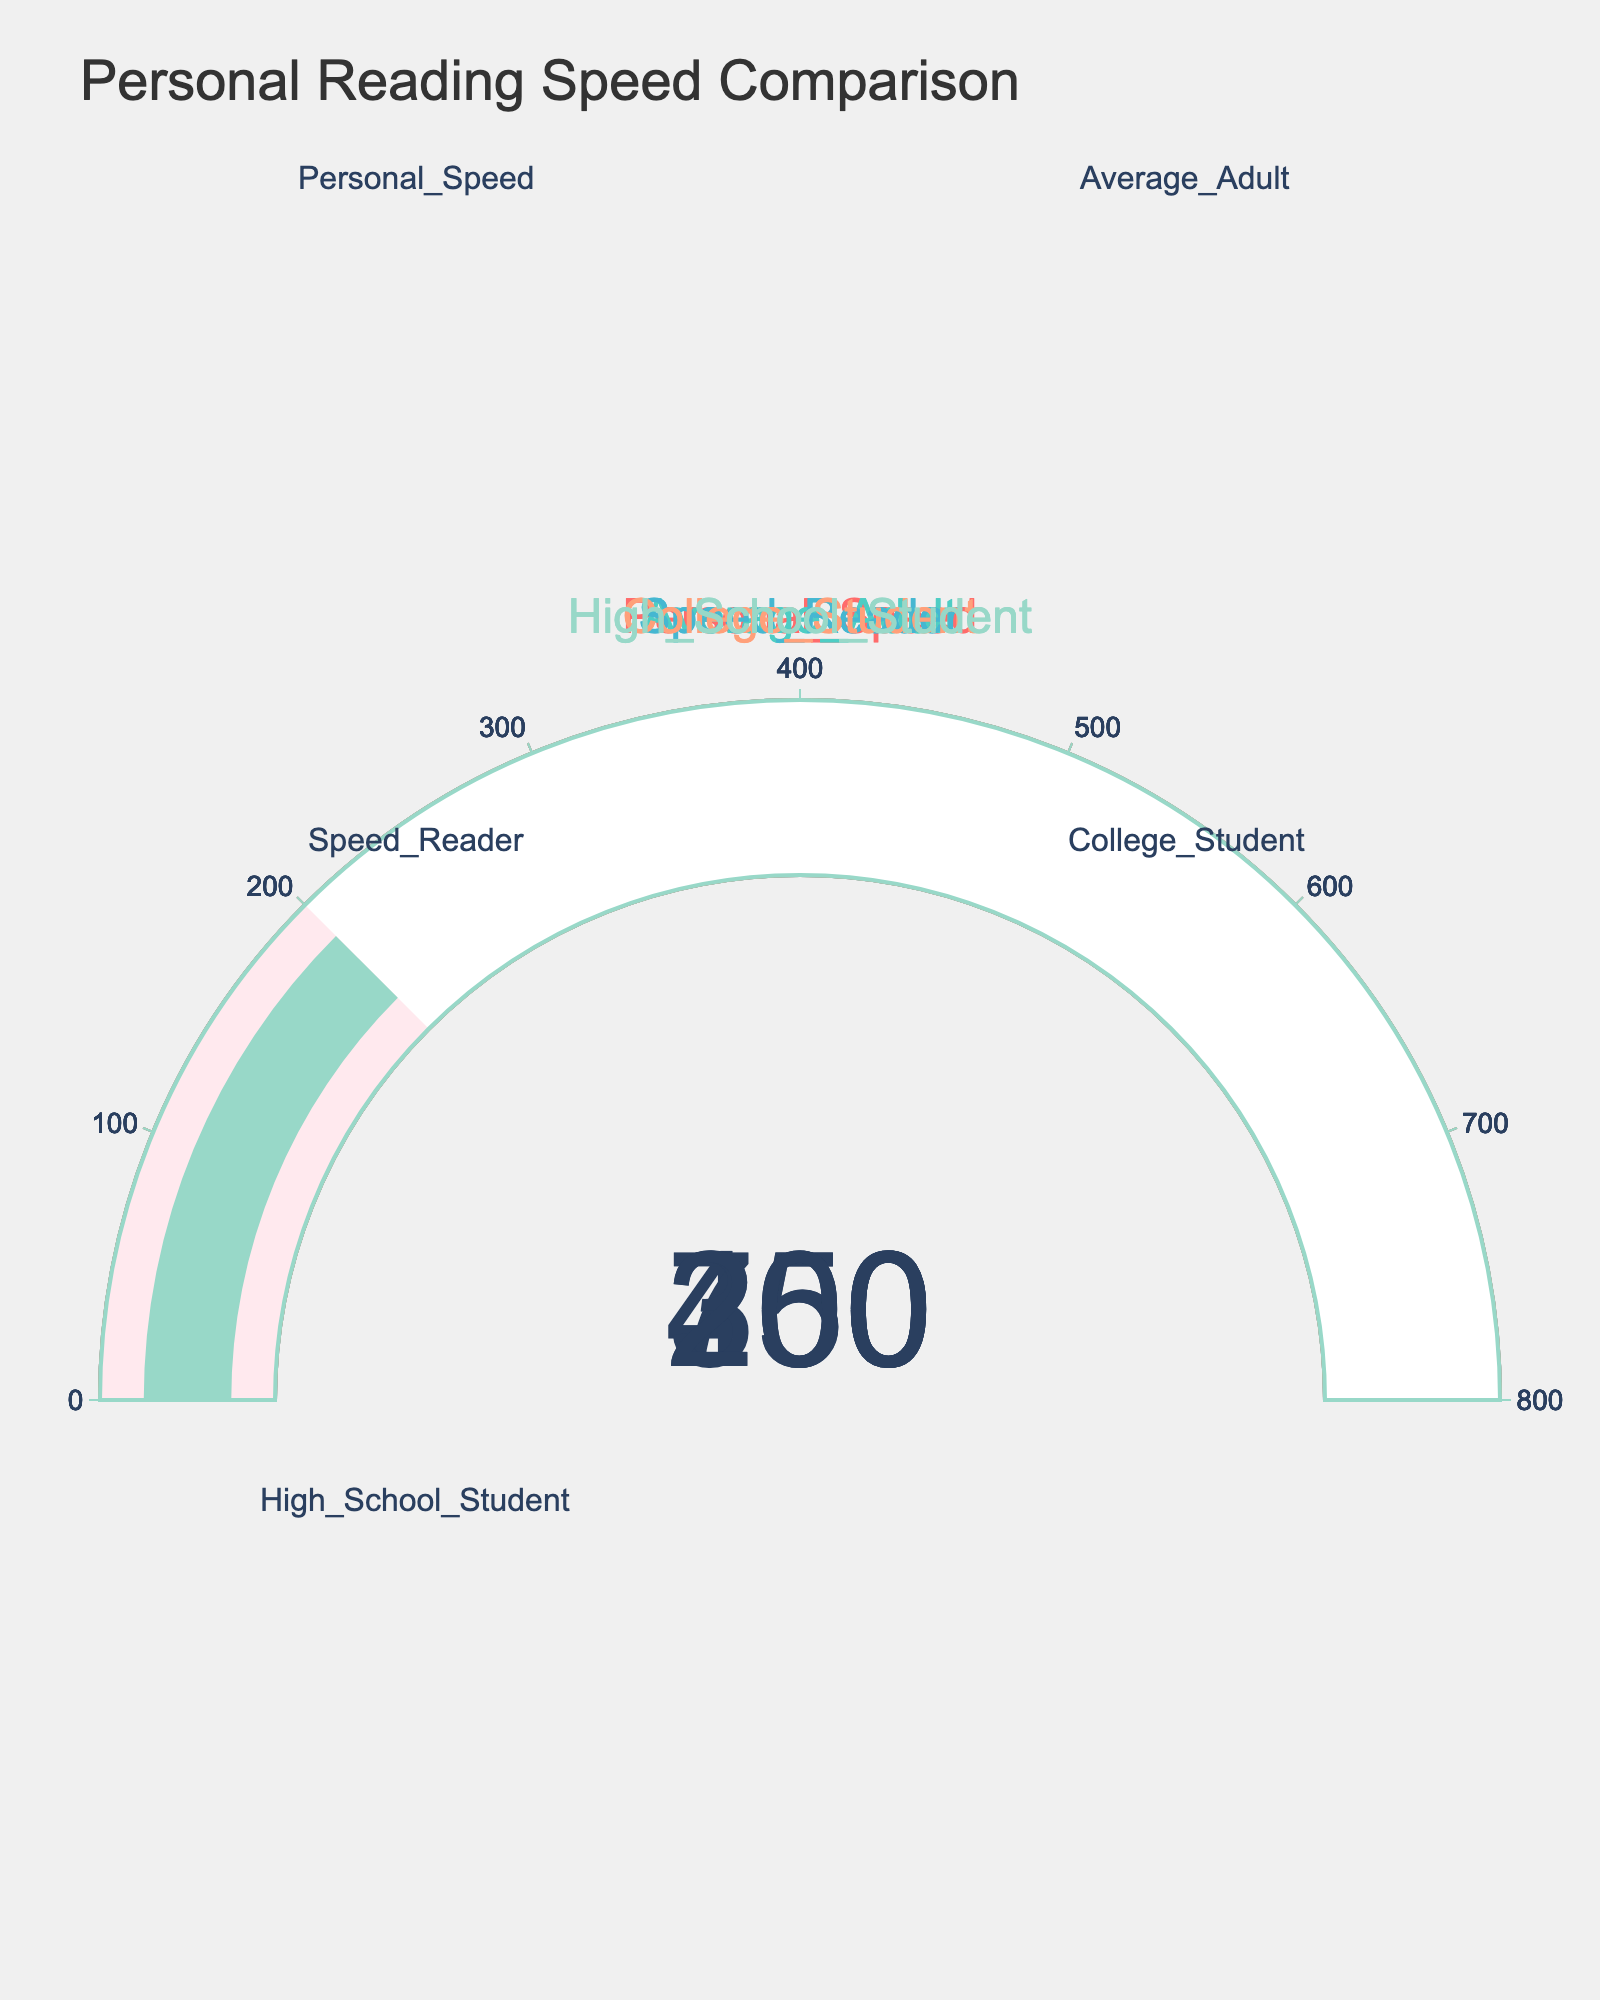what's the reading speed for a Personal Speed? The gauge chart for Personal Speed shows a value needle pointing at 450.
Answer: 450 how much faster is the Personal Speed compared to the Average Adult speed? Personal Speed is at 450 words per minute, and Average Adult is at 250 words per minute. The difference is 450 - 250 = 200 words per minute.
Answer: 200 which reading type has the highest speed? The Speed Reader gauge shows the highest value at 700 words per minute compared to other gauges.
Answer: Speed Reader is the College Student reading speed closer to the Average Adult or High School Student? College Student reads at 300 words per minute compared with 250 words per minute for the Average Adult and 200 words per minute for the High School Student. The difference to Average Adult is 50, and to High School Student is 100.
Answer: Average Adult how does the reading speed of a High School Student compare to the Personal Speed? The Personal Speed is 450 words per minute, and the High School Student speed is 200 words per minute. 450 - 200 = 250 words per minute difference, indicating that Personal Speed is 250 words per minute faster.
Answer: 250 